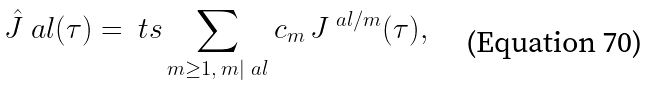<formula> <loc_0><loc_0><loc_500><loc_500>\hat { J } ^ { \ } a l ( \tau ) = \ t s \sum _ { m \geq 1 , \, m | \ a l } c _ { m } \, J ^ { \ a l / m } ( \tau ) ,</formula> 